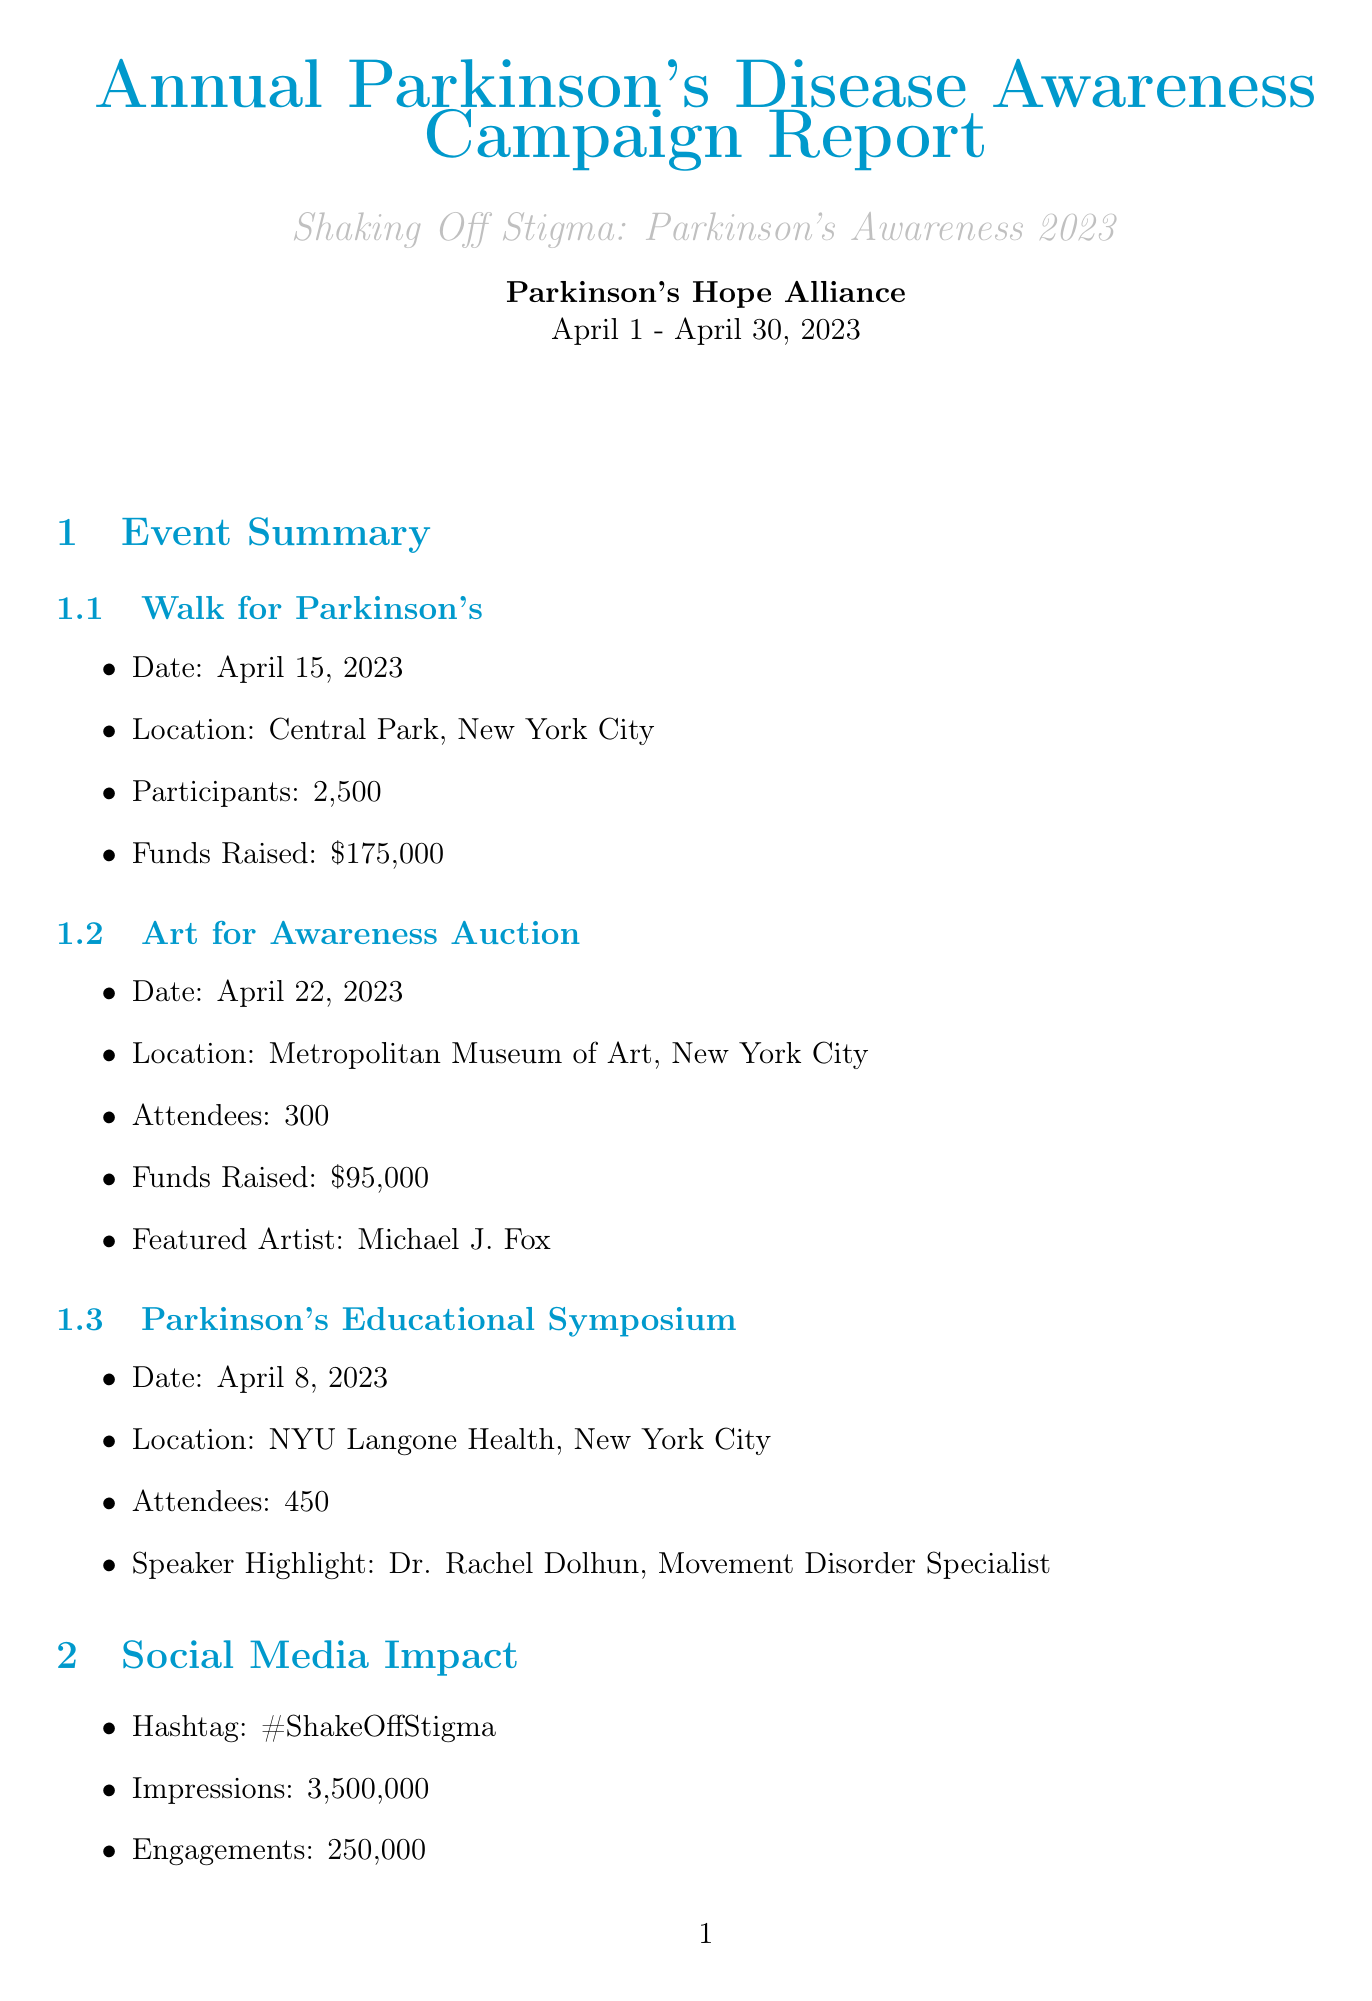what is the total funds raised? The total funds raised is stated in the fundraising breakdown section of the document, which shows a sum of different revenue sources.
Answer: 450000 who was the featured artist at the Art for Awareness Auction? The document specifies that the featured artist for this event was Michael J. Fox.
Answer: Michael J. Fox how many participants were in the Walk for Parkinson's? The event summary provides the number of participants for the Walk for Parkinson's event.
Answer: 2500 what was the date of the Parkinson's Educational Symposium? The event summary lists the date of the Parkinson's Educational Symposium.
Answer: April 8, 2023 which organization collaborated with Parkinson's Hope Alliance for this campaign? The document lists several collaborating organizations that worked with Parkinson's Hope Alliance on this campaign.
Answer: The Michael J. Fox Foundation how many new support group members were gained through the campaign? The awareness metrics section indicates this number, reflecting the campaign's impact on community involvement.
Answer: 130 what was the website traffic increase percentage? This metric is specifically mentioned in the awareness metrics section of the report.
Answer: 35% who is highlighted as the speaker for the Parkinson's Educational Symposium? The document specifies the prominent speaker at the educational symposium event.
Answer: Dr. Rachel Dolhun what is one future goal mentioned in the report? The document lists goals for future efforts, reflecting the organization's commitment to ongoing support.
Answer: Expand outreach to rural communities 